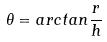Convert formula to latex. <formula><loc_0><loc_0><loc_500><loc_500>\theta = a r c t a n \frac { r } { h }</formula> 